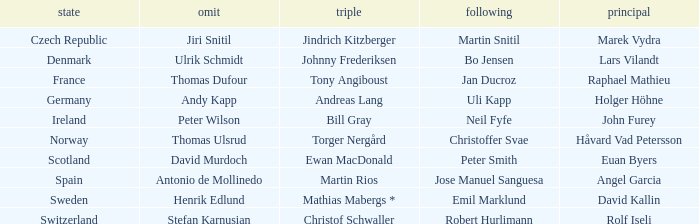When did holger höhne come in third? Andreas Lang. Can you give me this table as a dict? {'header': ['state', 'omit', 'triple', 'following', 'principal'], 'rows': [['Czech Republic', 'Jiri Snitil', 'Jindrich Kitzberger', 'Martin Snitil', 'Marek Vydra'], ['Denmark', 'Ulrik Schmidt', 'Johnny Frederiksen', 'Bo Jensen', 'Lars Vilandt'], ['France', 'Thomas Dufour', 'Tony Angiboust', 'Jan Ducroz', 'Raphael Mathieu'], ['Germany', 'Andy Kapp', 'Andreas Lang', 'Uli Kapp', 'Holger Höhne'], ['Ireland', 'Peter Wilson', 'Bill Gray', 'Neil Fyfe', 'John Furey'], ['Norway', 'Thomas Ulsrud', 'Torger Nergård', 'Christoffer Svae', 'Håvard Vad Petersson'], ['Scotland', 'David Murdoch', 'Ewan MacDonald', 'Peter Smith', 'Euan Byers'], ['Spain', 'Antonio de Mollinedo', 'Martin Rios', 'Jose Manuel Sanguesa', 'Angel Garcia'], ['Sweden', 'Henrik Edlund', 'Mathias Mabergs *', 'Emil Marklund', 'David Kallin'], ['Switzerland', 'Stefan Karnusian', 'Christof Schwaller', 'Robert Hurlimann', 'Rolf Iseli']]} 